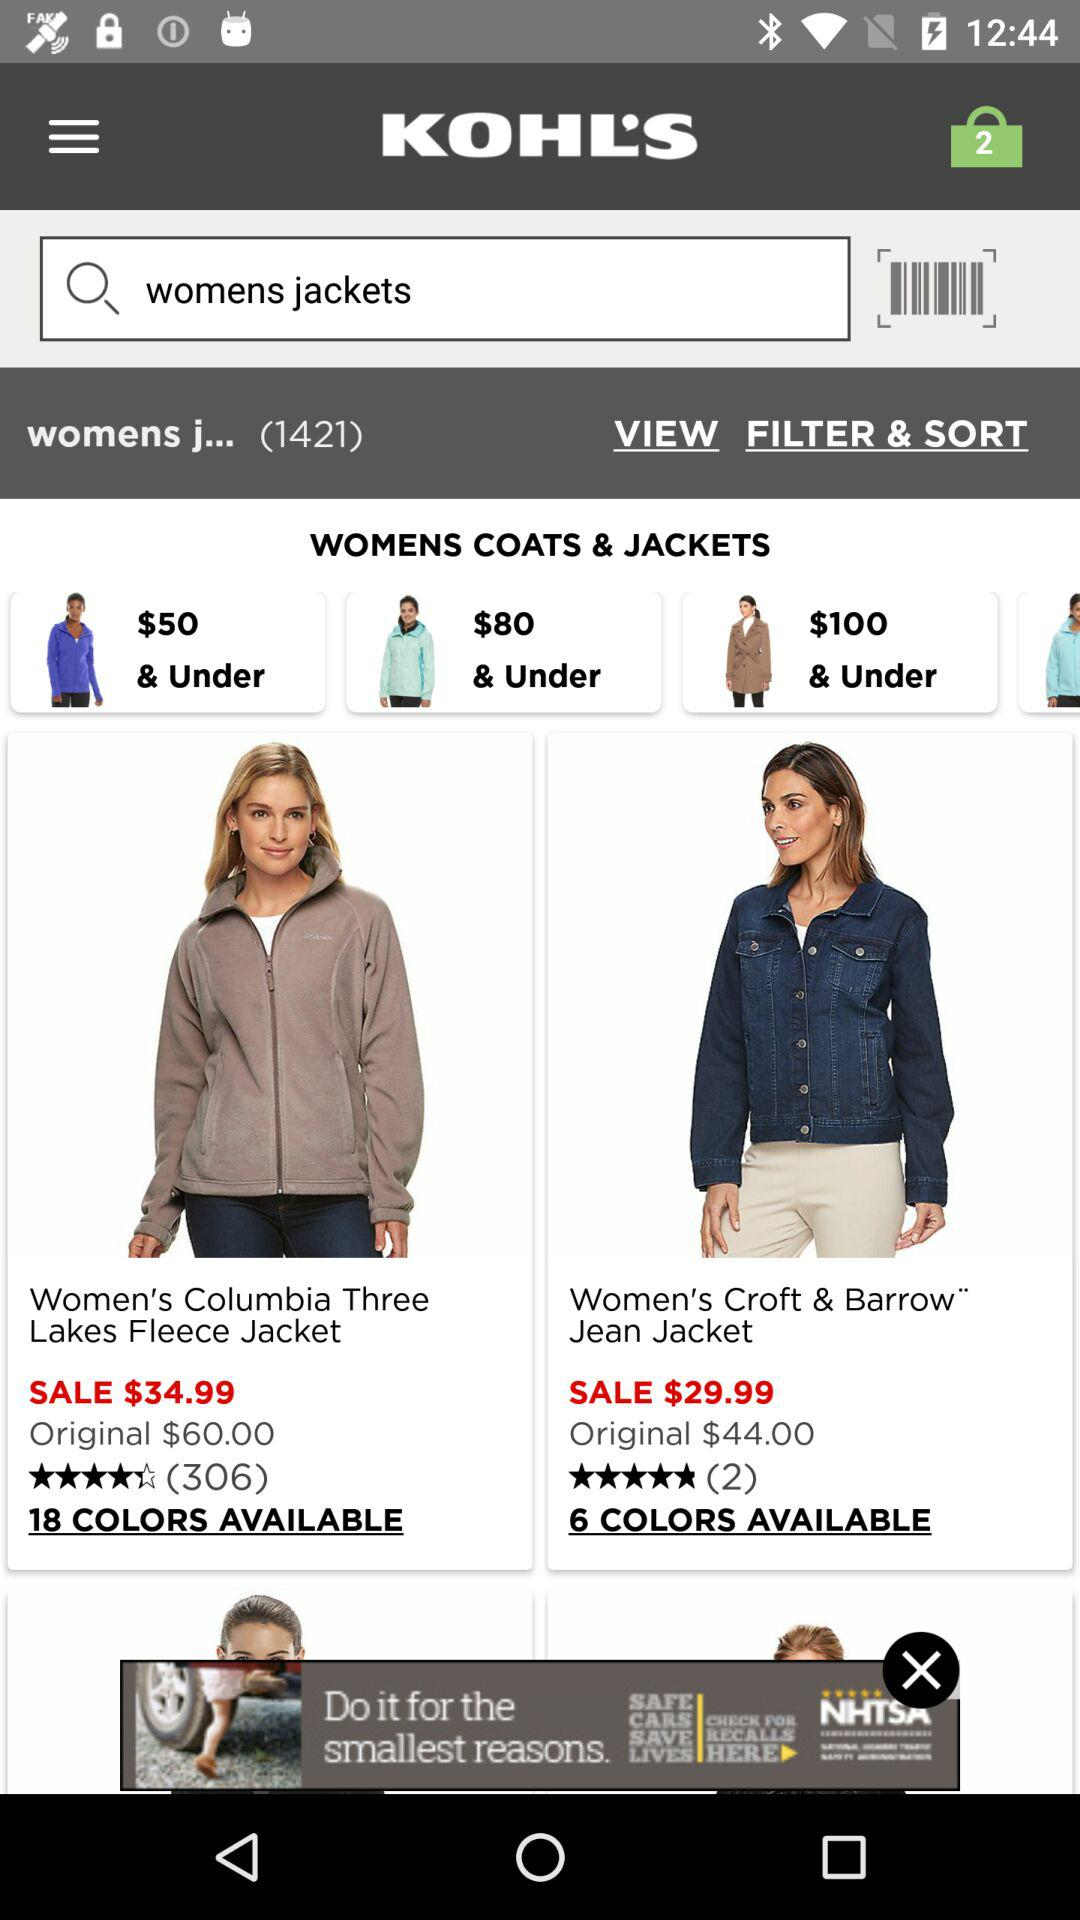How much is the sale price for the Croft & BarrowTM Jean Jacket?
Answer the question using a single word or phrase. $29.99 